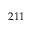<formula> <loc_0><loc_0><loc_500><loc_500>2 1 1</formula> 